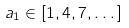<formula> <loc_0><loc_0><loc_500><loc_500>a _ { 1 } \in [ 1 , 4 , 7 , \dots ]</formula> 